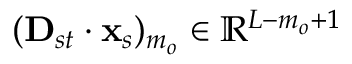<formula> <loc_0><loc_0><loc_500><loc_500>( D _ { s t } \cdot x _ { s } ) _ { m _ { o } } \in \mathbb { R } ^ { L - m _ { o } + 1 }</formula> 